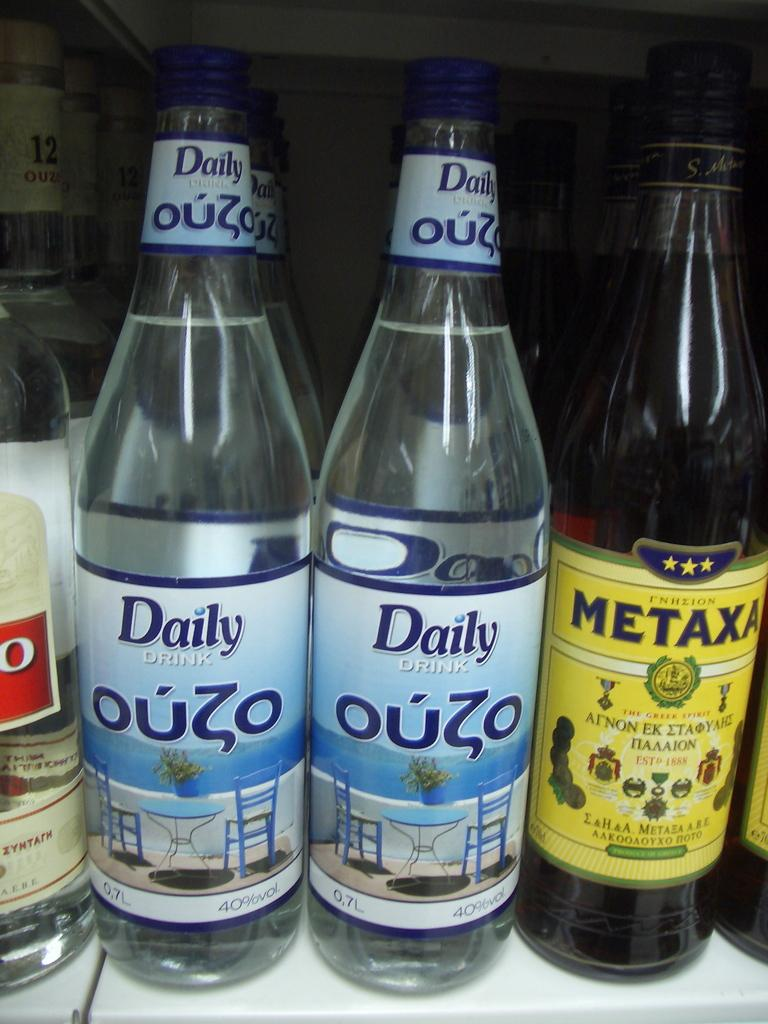<image>
Write a terse but informative summary of the picture. Two bottles of Daily Drink Ouzo in between some other bottles. 